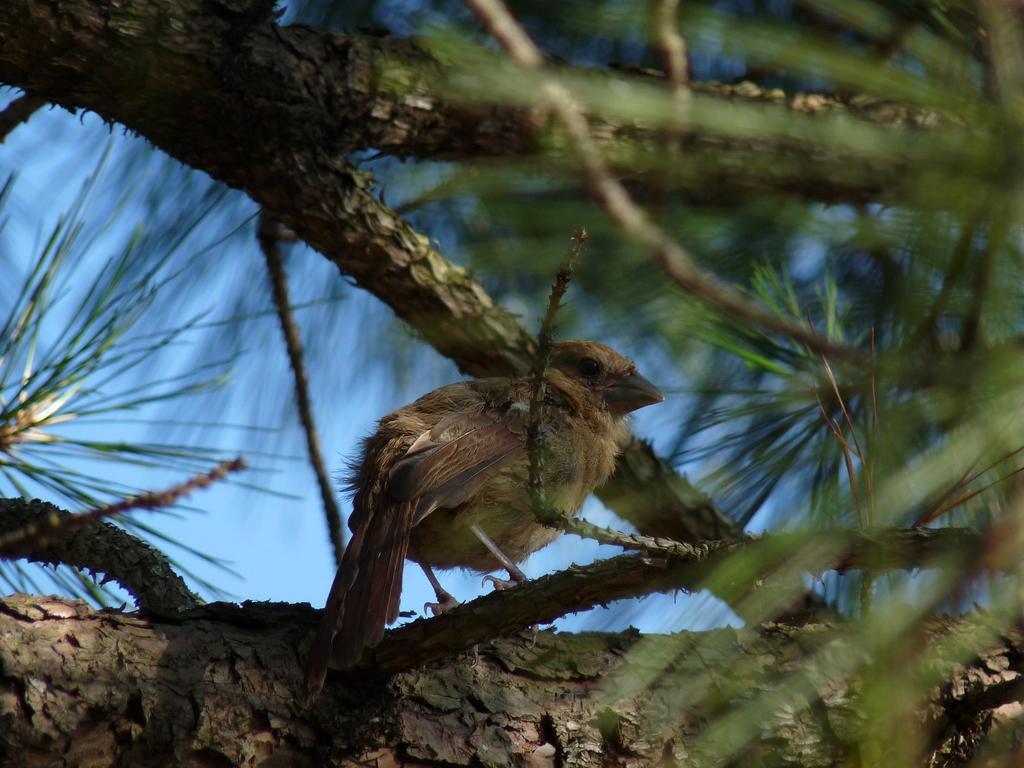In one or two sentences, can you explain what this image depicts? In this image there is a bird on the branch of the tree and the sky. 